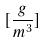Convert formula to latex. <formula><loc_0><loc_0><loc_500><loc_500>[ \frac { g } { m ^ { 3 } } ]</formula> 